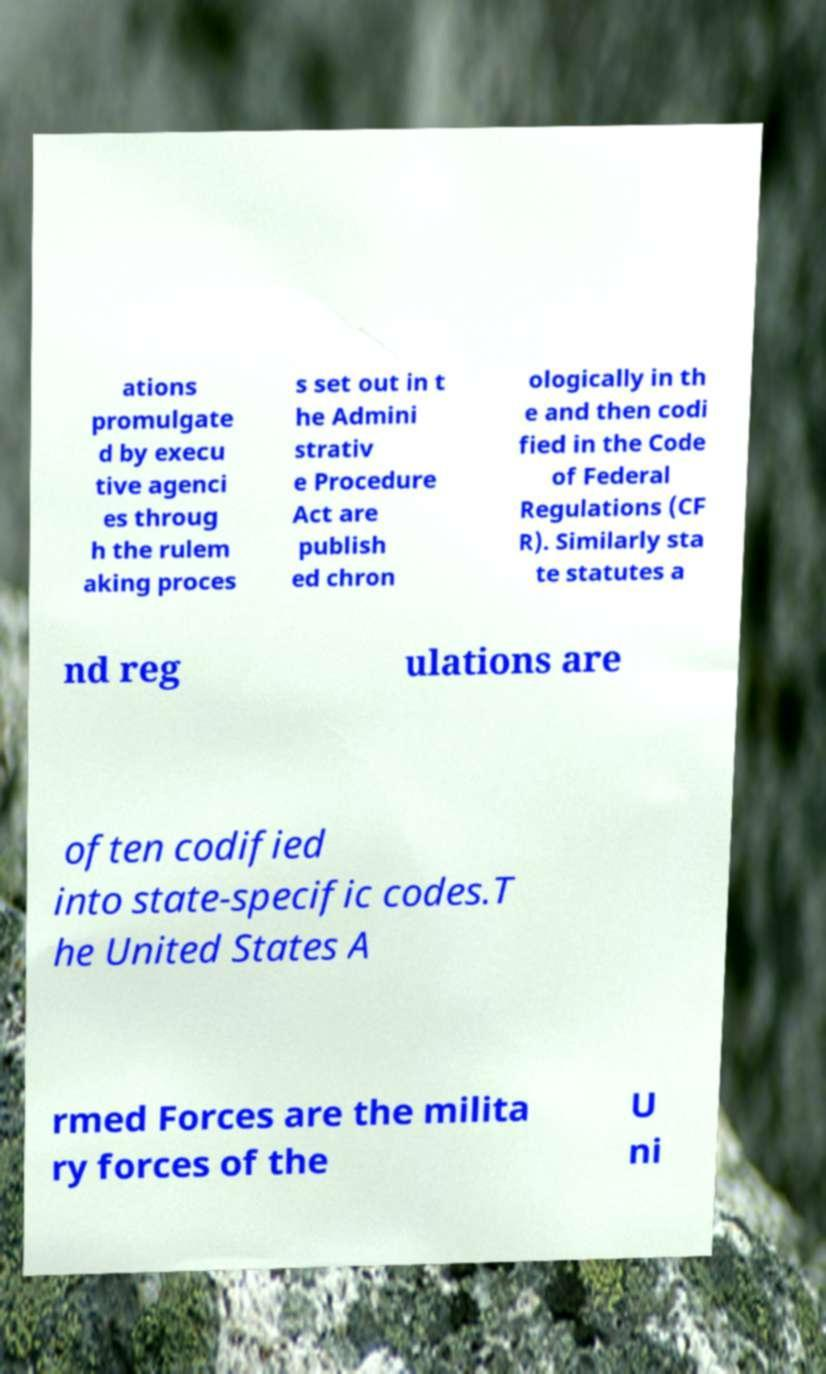I need the written content from this picture converted into text. Can you do that? ations promulgate d by execu tive agenci es throug h the rulem aking proces s set out in t he Admini strativ e Procedure Act are publish ed chron ologically in th e and then codi fied in the Code of Federal Regulations (CF R). Similarly sta te statutes a nd reg ulations are often codified into state-specific codes.T he United States A rmed Forces are the milita ry forces of the U ni 